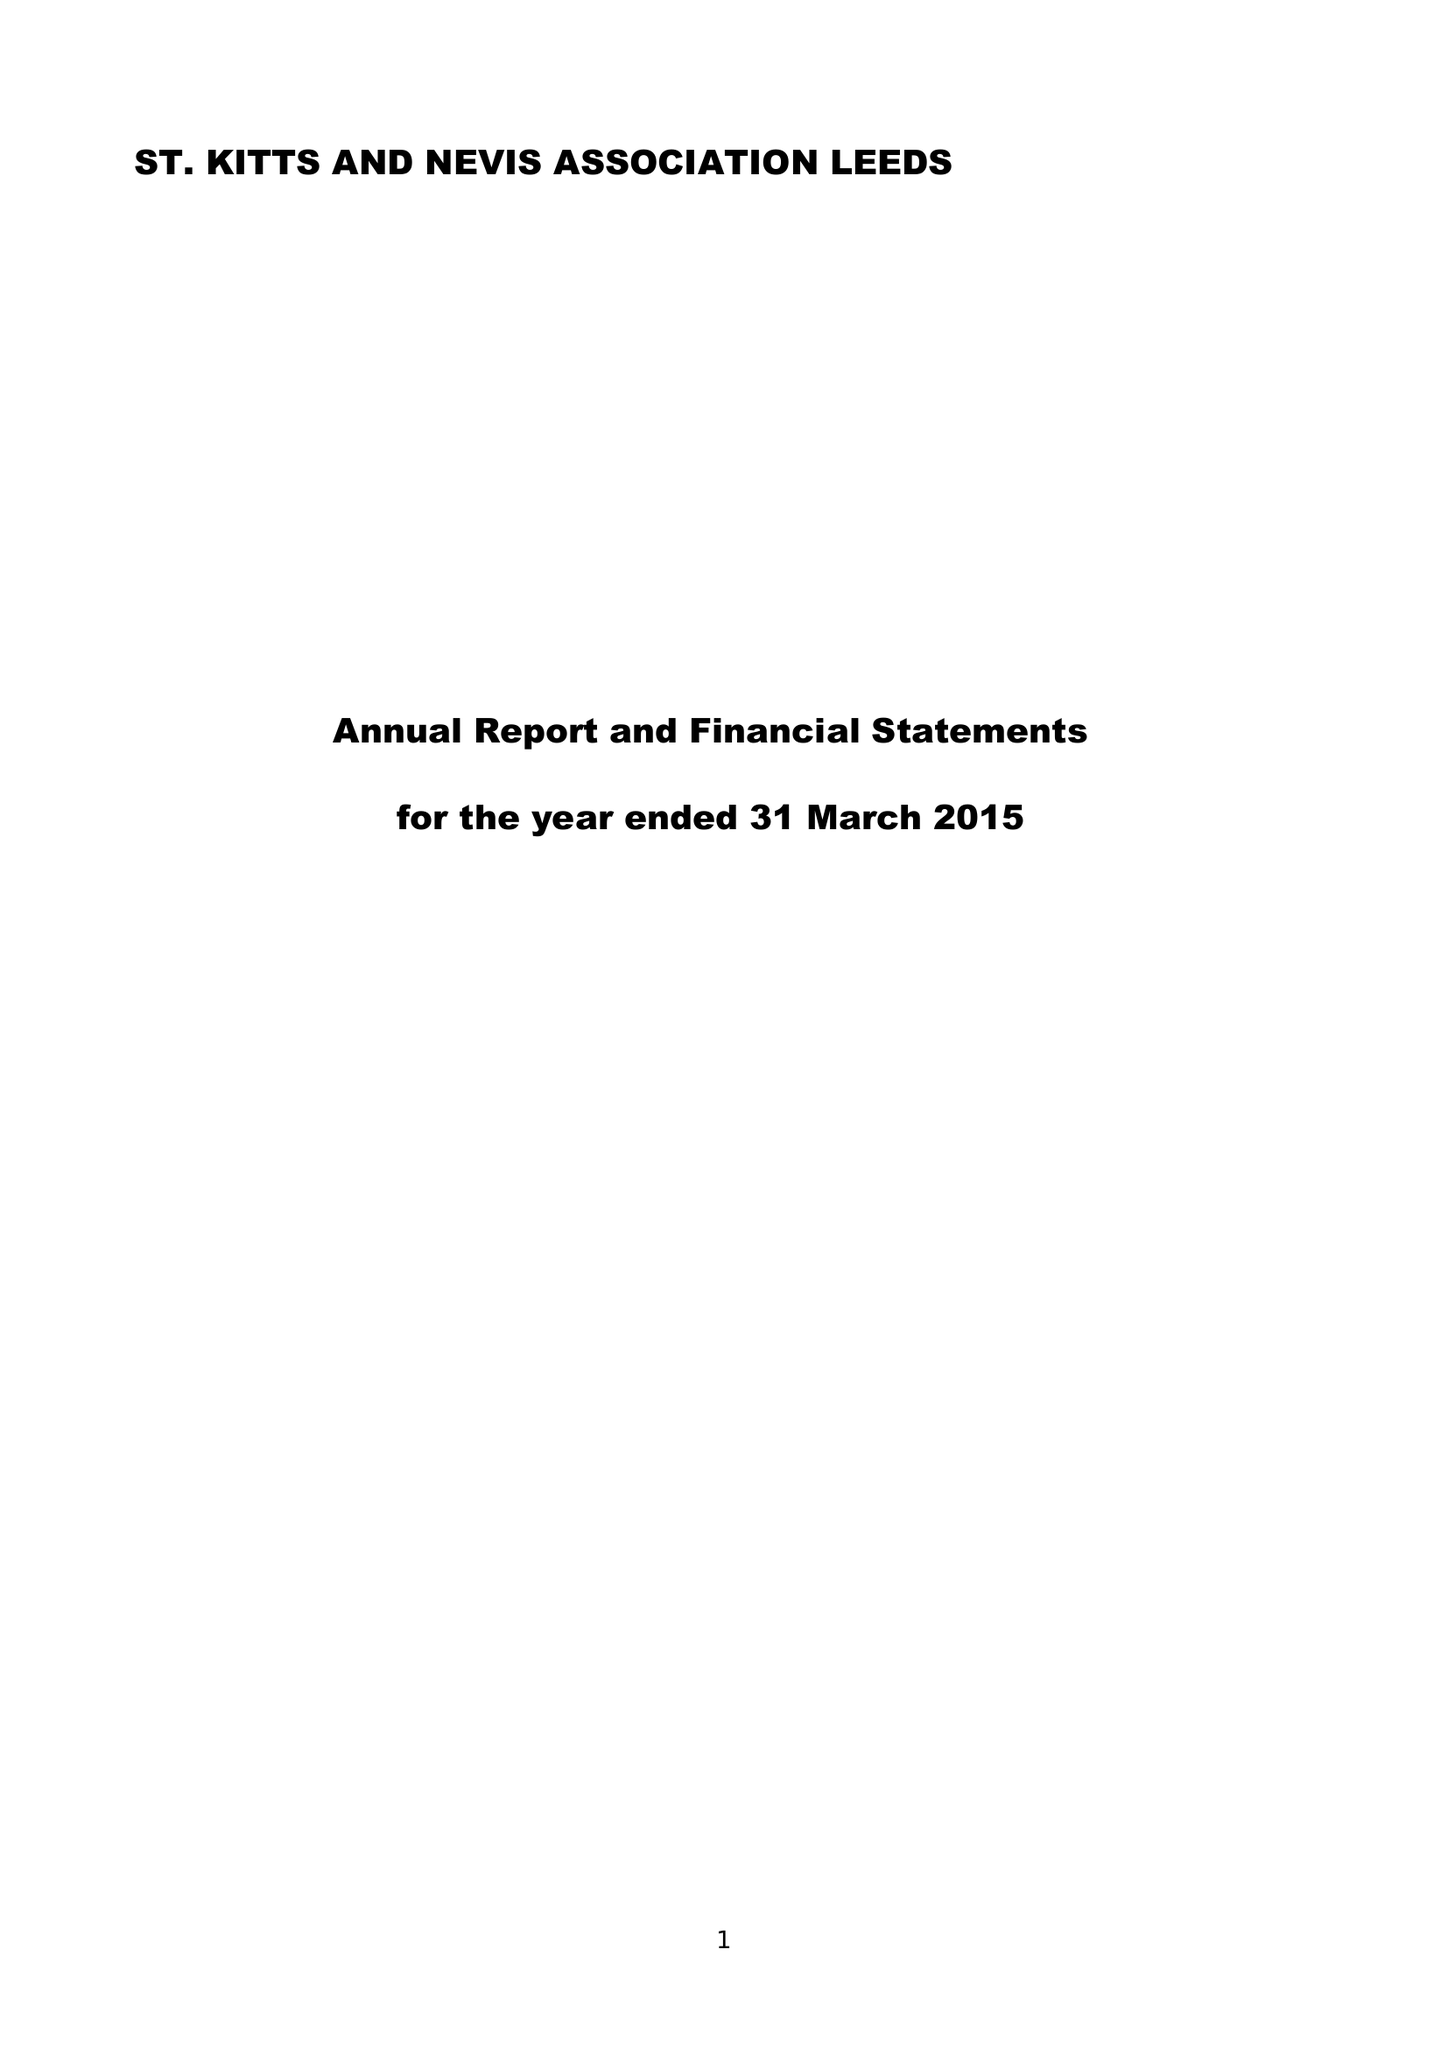What is the value for the spending_annually_in_british_pounds?
Answer the question using a single word or phrase. 31372.00 